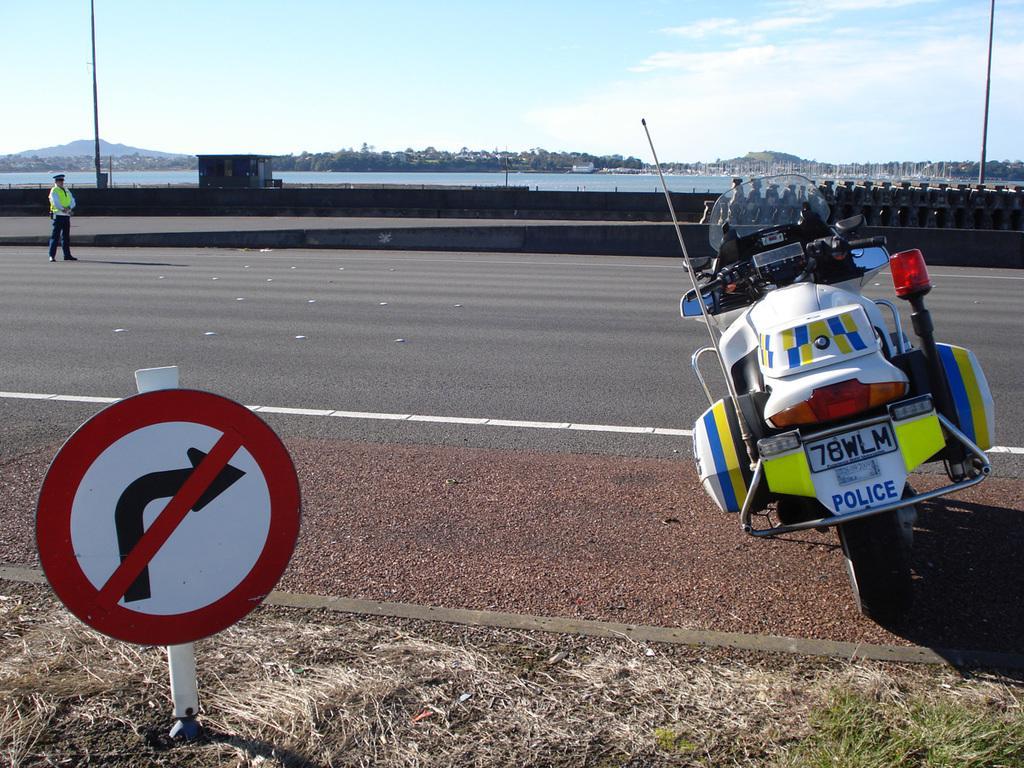Can you describe this image briefly? In this image we can see mountains, river, one bridge, one fence, one small house, so many trees, one vehicle on the road, one sign board, some grass on the surface, one person standing on the road and at the top there is the sky. 